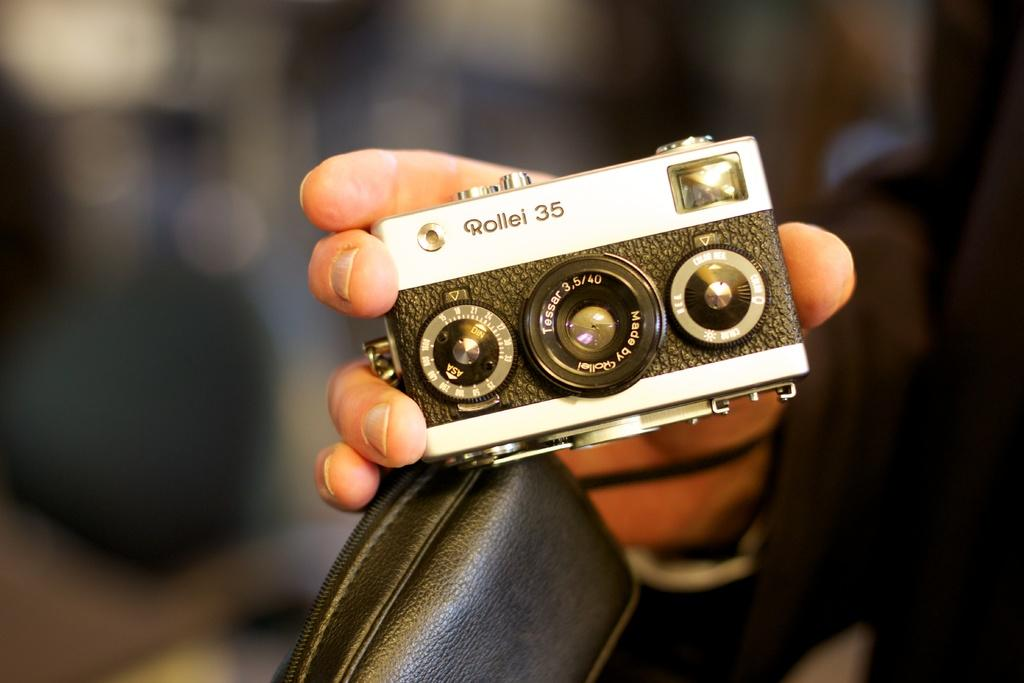<image>
Create a compact narrative representing the image presented. Person holding a mini camera that says Rollel 35 on it. 